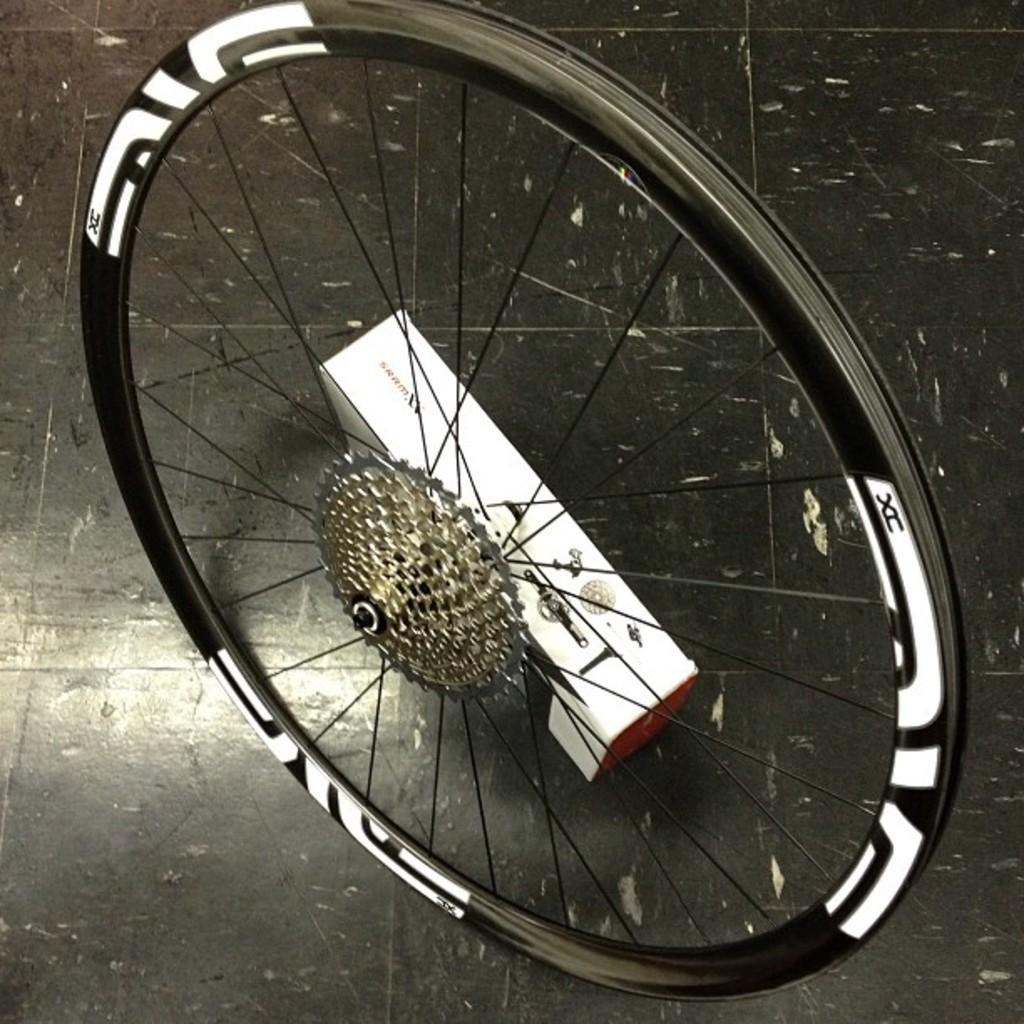How would you summarize this image in a sentence or two? In this picture I can see the bicycles which is kept on the floor, beside that there is a white color box. 